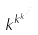<formula> <loc_0><loc_0><loc_500><loc_500>k ^ { k ^ { k ^ { \cdot ^ { \cdot ^ { \cdot } } } } }</formula> 